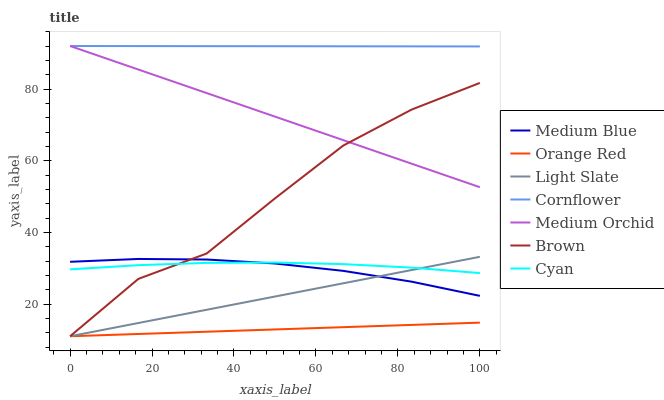Does Brown have the minimum area under the curve?
Answer yes or no. No. Does Brown have the maximum area under the curve?
Answer yes or no. No. Is Light Slate the smoothest?
Answer yes or no. No. Is Light Slate the roughest?
Answer yes or no. No. Does Medium Orchid have the lowest value?
Answer yes or no. No. Does Brown have the highest value?
Answer yes or no. No. Is Brown less than Cornflower?
Answer yes or no. Yes. Is Cornflower greater than Orange Red?
Answer yes or no. Yes. Does Brown intersect Cornflower?
Answer yes or no. No. 